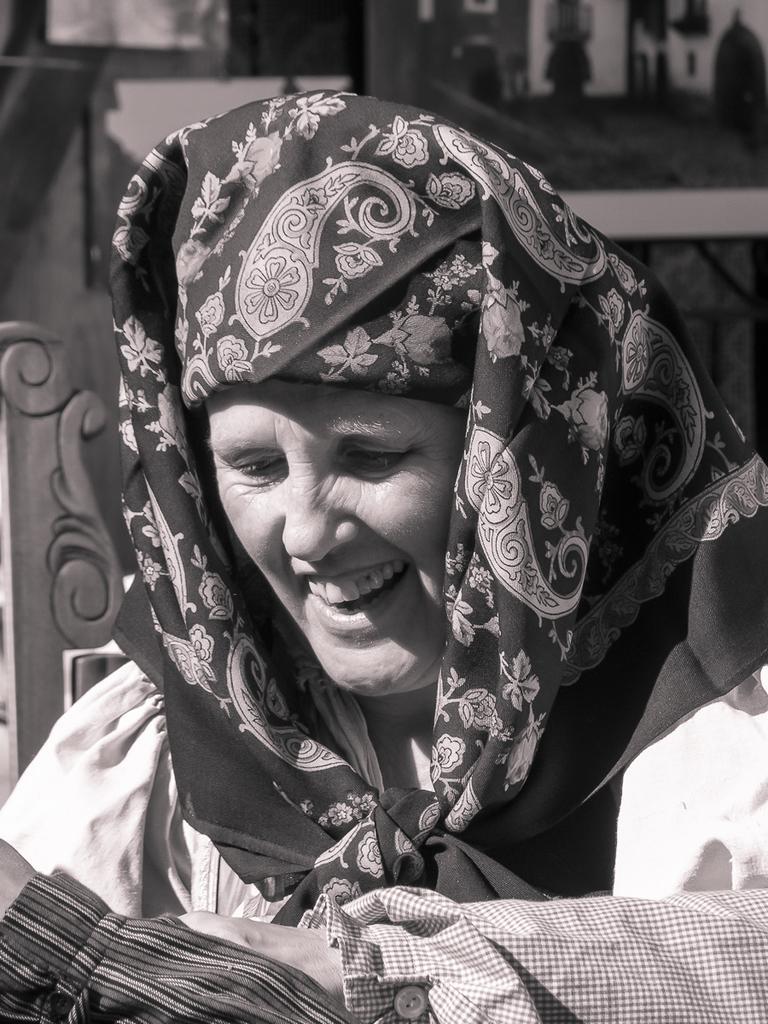Please provide a concise description of this image. In this image there is a woman having a smile on her face. 